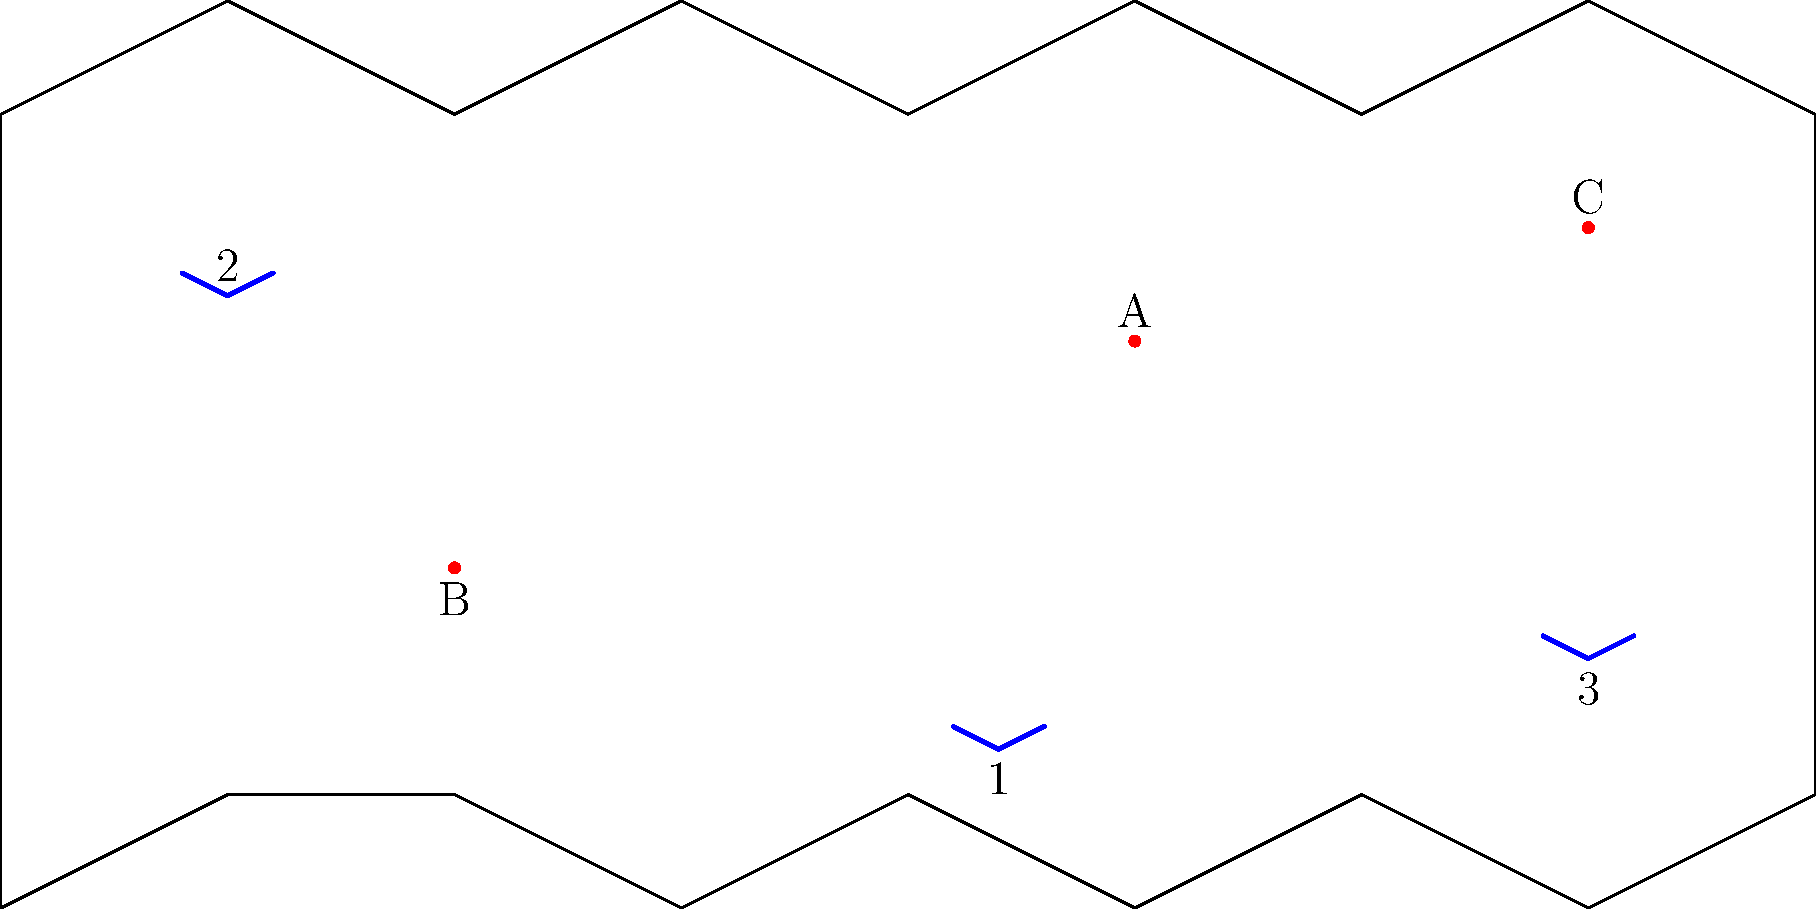Based on the global projection showing the strategic placement of nuclear silos (A, B, C) and submarines (1, 2, 3), which combination of assets would provide the most comprehensive nuclear deterrent coverage? Consider factors such as geographical distribution and mobility. To determine the most comprehensive nuclear deterrent coverage, we need to consider the following factors:

1. Geographical distribution: Assets should be spread out to cover different regions of the globe.
2. Mobility: Submarines offer mobility, while silos are stationary but more heavily protected.
3. Redundancy: Having both mobile and stationary assets increases the reliability of the deterrent.

Let's analyze the options:

1. Silos:
   A: Northern hemisphere, eastern region
   B: Southern hemisphere, western region
   C: Northern hemisphere, eastern region (similar to A)

2. Submarines:
   1: Southern hemisphere, central region
   2: Northern hemisphere, western region
   3: Southern hemisphere, eastern region

The most comprehensive coverage would include:

- One silo from the northern hemisphere (A or C)
- The silo from the southern hemisphere (B)
- Two submarines from different hemispheres

The best combination would be:

- Silo A (northern hemisphere, eastern)
- Silo B (southern hemisphere, western)
- Submarine 2 (northern hemisphere, western)
- Submarine 3 (southern hemisphere, eastern)

This combination provides:
1. Coverage in both northern and southern hemispheres
2. Distribution across eastern and western regions
3. A mix of stationary (silos) and mobile (submarines) assets
4. Redundancy in each hemisphere
Answer: Silos A and B, Submarines 2 and 3 